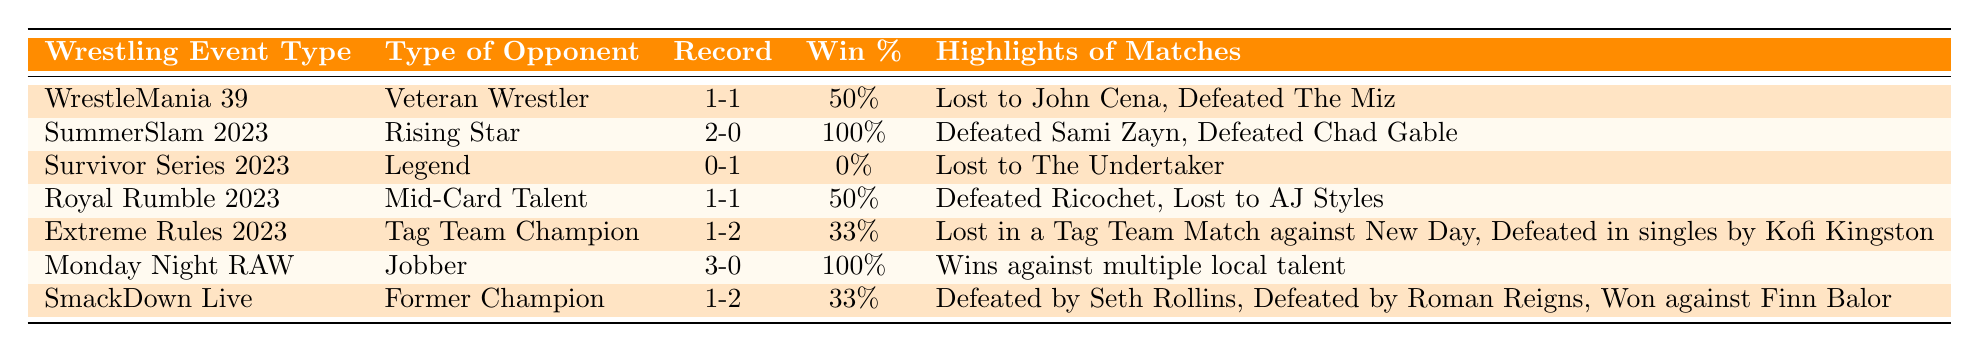What is the win-loss record against Rising Stars? The win-loss record against Rising Stars is found under the "Opponent Type" for SummerSlam 2023, which shows a record of 2-0.
Answer: 2-0 Which event saw the highest win percentage? The event with the highest win percentage is SummerSlam 2023, where the win percentage is 100% from a record of 2-0.
Answer: SummerSlam 2023 How many total wins and losses do you have against Jobbers? The total record against Jobbers, shown in Monday Night RAW, is 3-0, which is 3 wins and 0 losses.
Answer: 3 wins, 0 losses What percentage of matches were won against Veteran Wrestlers? The record against Veteran Wrestlers from WrestleMania 39 is 1-1, indicating one win out of two matches, which gives a win percentage of 50%.
Answer: 50% Did you ever defeat a Legend in 2023? The record against Legends at Survivor Series 2023 is 0-1, indicating no wins were recorded against them.
Answer: No What is the average win percentage against Tag Team Champions and Former Champions? The win percentage against Tag Team Champions is 33% (1-2 record), and against Former Champions is also 33% (1-2 record). The average is (33% + 33%) / 2 = 33%.
Answer: 33% How many events showed a win percentage of less than 50%? The events with win percentages below 50% are Survivor Series 2023 (0%), Extreme Rules 2023 (33%), and SmackDown Live (33%). That totals three events.
Answer: 3 events Is it true you won all your matches against Jobbers? Yes, the record against Jobbers in Monday Night RAW shows a 3-0 win-loss record, which means all wins.
Answer: Yes What were the notable matches in the event where you faced Mid-Card Talent? The notable matches from Royal Rumble 2023, where I faced Mid-Card Talent, include defeating Ricochet and losing to AJ Styles.
Answer: Defeated Ricochet, Lost to AJ Styles Did you lose to any opponent type more than you won against? Yes, in the case of Tag Team Champions, the record is 1-2, indicating more losses (2) than wins (1).
Answer: Yes 